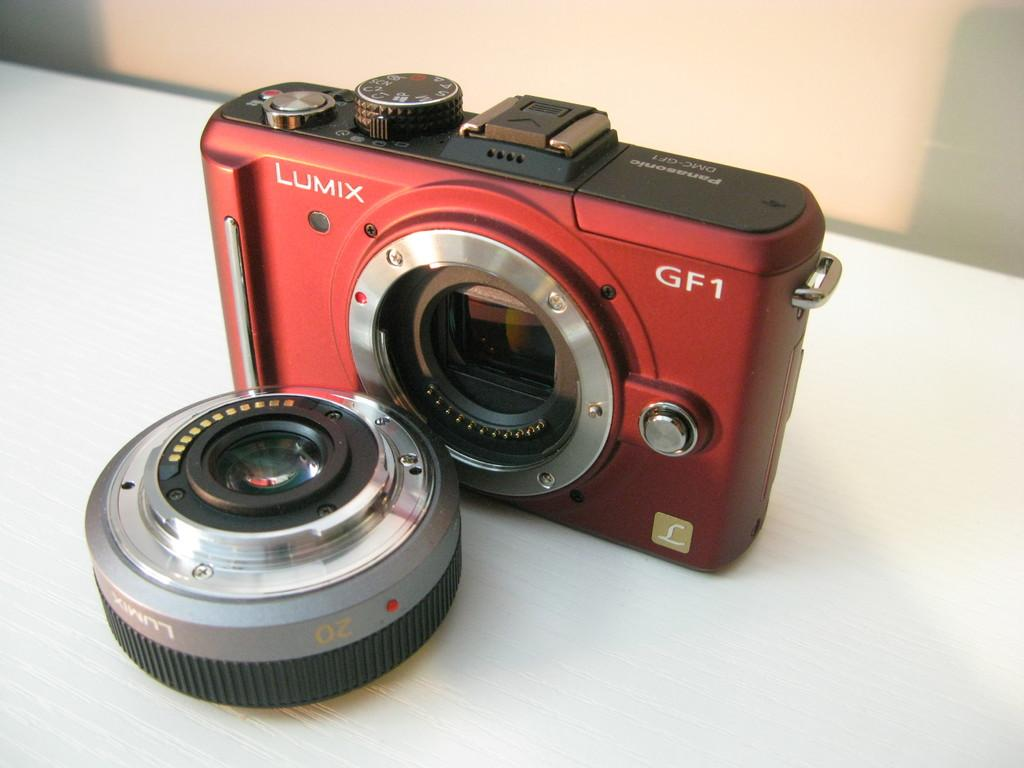What color is the camera in the image? The camera is dark red in color. Can you describe any specific features of the camera? Yes, there is a camera lens on the left side of the camera. How much debt does the carpenter owe to the cattle in the image? There is no carpenter, debt, or cattle present in the image. 